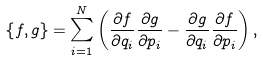Convert formula to latex. <formula><loc_0><loc_0><loc_500><loc_500>\left \{ f , g \right \} = \sum _ { i = 1 } ^ { N } \left ( \frac { \partial f } { \partial q _ { i } } \frac { \partial g } { \partial p _ { i } } - \frac { \partial g } { \partial q _ { i } } \frac { \partial f } { \partial p _ { i } } \right ) ,</formula> 